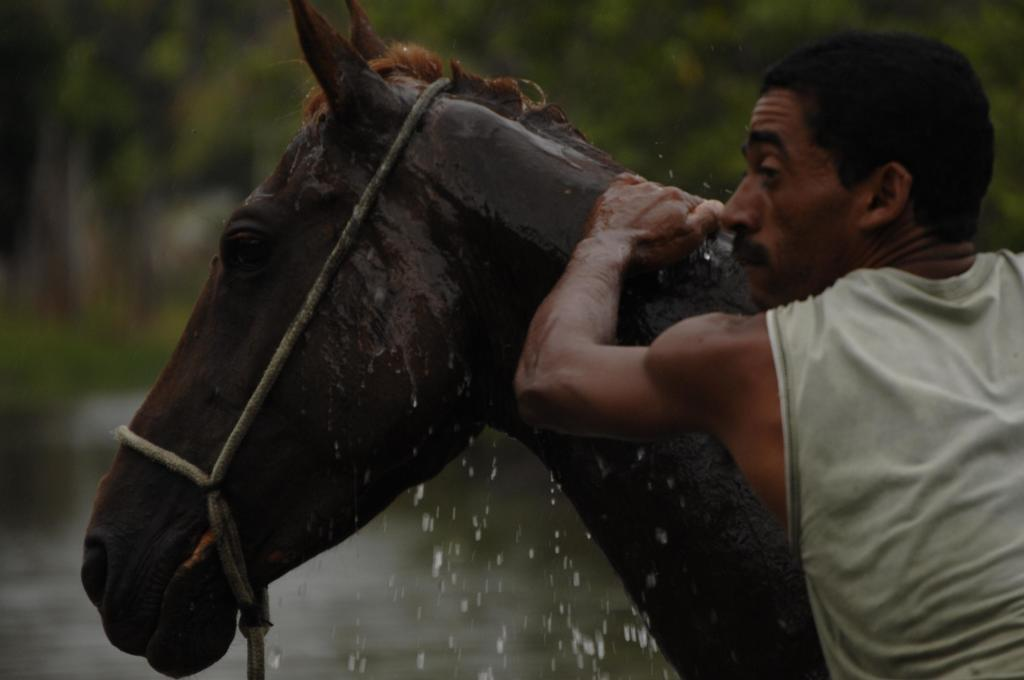What is the main subject of the image? The main subject of the image is a horse. What is the man in the image doing? The man is touching the horse. Can you describe any specific details about the image? There are a few droplets of water visible in the image. How would you describe the background of the image? The background of the image is blurry. What type of string is being used to tie the plantation in the image? There is no string or plantation present in the image; it features a horse and a man touching the horse. How many birds can be seen flying in the image? There are no birds visible in the image. 